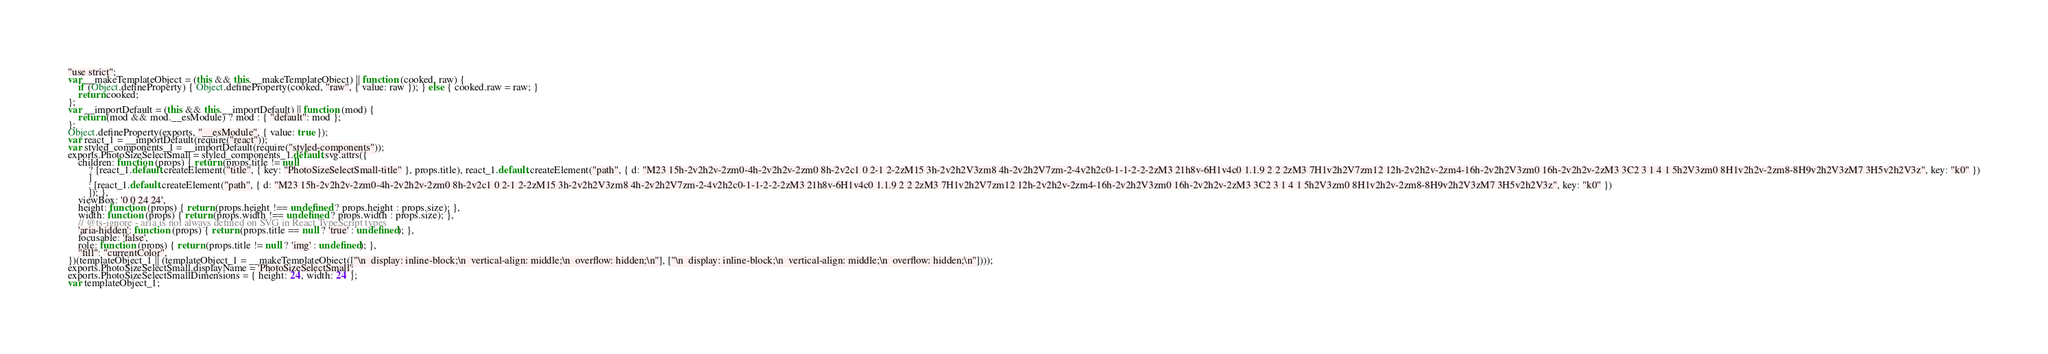Convert code to text. <code><loc_0><loc_0><loc_500><loc_500><_JavaScript_>"use strict";
var __makeTemplateObject = (this && this.__makeTemplateObject) || function (cooked, raw) {
    if (Object.defineProperty) { Object.defineProperty(cooked, "raw", { value: raw }); } else { cooked.raw = raw; }
    return cooked;
};
var __importDefault = (this && this.__importDefault) || function (mod) {
    return (mod && mod.__esModule) ? mod : { "default": mod };
};
Object.defineProperty(exports, "__esModule", { value: true });
var react_1 = __importDefault(require("react"));
var styled_components_1 = __importDefault(require("styled-components"));
exports.PhotoSizeSelectSmall = styled_components_1.default.svg.attrs({
    children: function (props) { return (props.title != null
        ? [react_1.default.createElement("title", { key: "PhotoSizeSelectSmall-title" }, props.title), react_1.default.createElement("path", { d: "M23 15h-2v2h2v-2zm0-4h-2v2h2v-2zm0 8h-2v2c1 0 2-1 2-2zM15 3h-2v2h2V3zm8 4h-2v2h2V7zm-2-4v2h2c0-1-1-2-2-2zM3 21h8v-6H1v4c0 1.1.9 2 2 2zM3 7H1v2h2V7zm12 12h-2v2h2v-2zm4-16h-2v2h2V3zm0 16h-2v2h2v-2zM3 3C2 3 1 4 1 5h2V3zm0 8H1v2h2v-2zm8-8H9v2h2V3zM7 3H5v2h2V3z", key: "k0" })
        ]
        : [react_1.default.createElement("path", { d: "M23 15h-2v2h2v-2zm0-4h-2v2h2v-2zm0 8h-2v2c1 0 2-1 2-2zM15 3h-2v2h2V3zm8 4h-2v2h2V7zm-2-4v2h2c0-1-1-2-2-2zM3 21h8v-6H1v4c0 1.1.9 2 2 2zM3 7H1v2h2V7zm12 12h-2v2h2v-2zm4-16h-2v2h2V3zm0 16h-2v2h2v-2zM3 3C2 3 1 4 1 5h2V3zm0 8H1v2h2v-2zm8-8H9v2h2V3zM7 3H5v2h2V3z", key: "k0" })
        ]); },
    viewBox: '0 0 24 24',
    height: function (props) { return (props.height !== undefined ? props.height : props.size); },
    width: function (props) { return (props.width !== undefined ? props.width : props.size); },
    // @ts-ignore - aria is not always defined on SVG in React TypeScript types
    'aria-hidden': function (props) { return (props.title == null ? 'true' : undefined); },
    focusable: 'false',
    role: function (props) { return (props.title != null ? 'img' : undefined); },
    "fill": "currentColor",
})(templateObject_1 || (templateObject_1 = __makeTemplateObject(["\n  display: inline-block;\n  vertical-align: middle;\n  overflow: hidden;\n"], ["\n  display: inline-block;\n  vertical-align: middle;\n  overflow: hidden;\n"])));
exports.PhotoSizeSelectSmall.displayName = 'PhotoSizeSelectSmall';
exports.PhotoSizeSelectSmallDimensions = { height: 24, width: 24 };
var templateObject_1;
</code> 